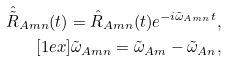Convert formula to latex. <formula><loc_0><loc_0><loc_500><loc_500>\hat { \tilde { R } } _ { A m n } ( t ) = \hat { R } _ { A m n } ( t ) e ^ { - i \tilde { \omega } _ { A m n } t } , \\ [ 1 e x ] \tilde { \omega } _ { A m n } = \tilde { \omega } _ { A m } - \tilde { \omega } _ { A n } ,</formula> 